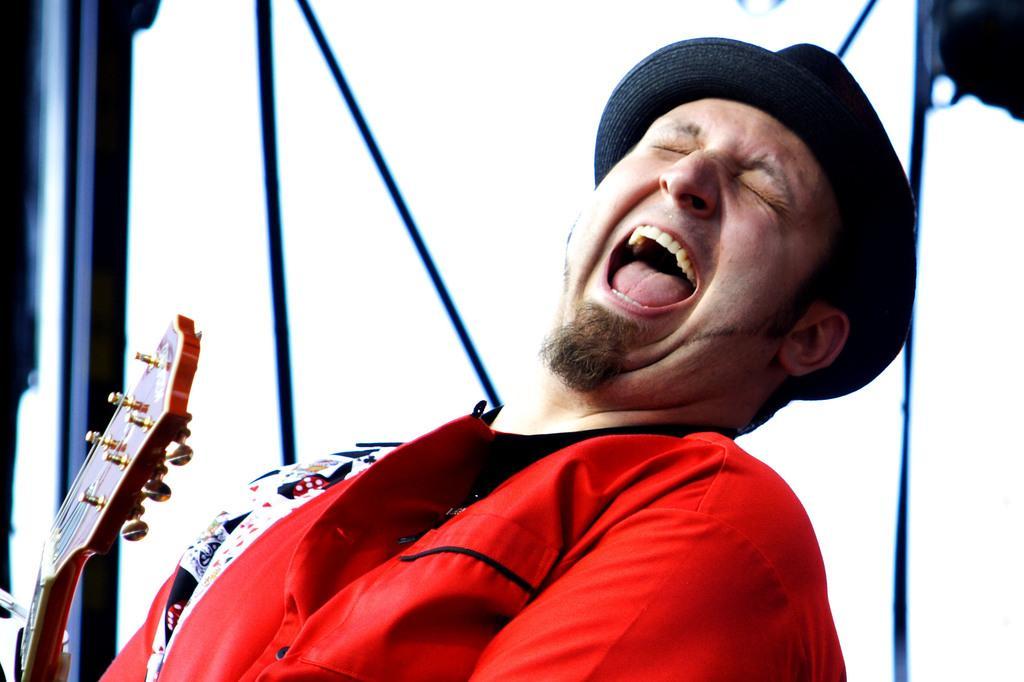How would you summarize this image in a sentence or two? Here a man closes his eyes and opened his mouth. On the left there is a guitar. 